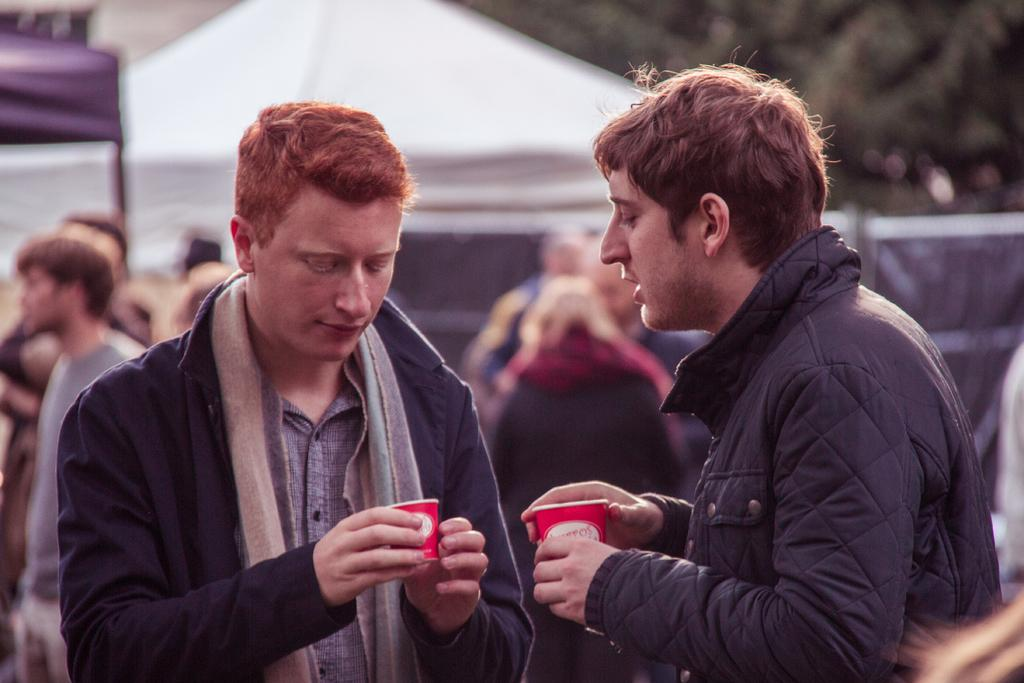How many people are in the image? There are two men standing in the image. What are the men holding in their hands? The men are holding cups in their hands. What can be seen in the background of the image? There are tents in the background of the image. Can you describe the quality of the background? The background is blurry. What color crayon is being used to draw on the need in the image? There is no crayon or need present in the image. How many basins are visible in the image? There are no basins visible in the image. 